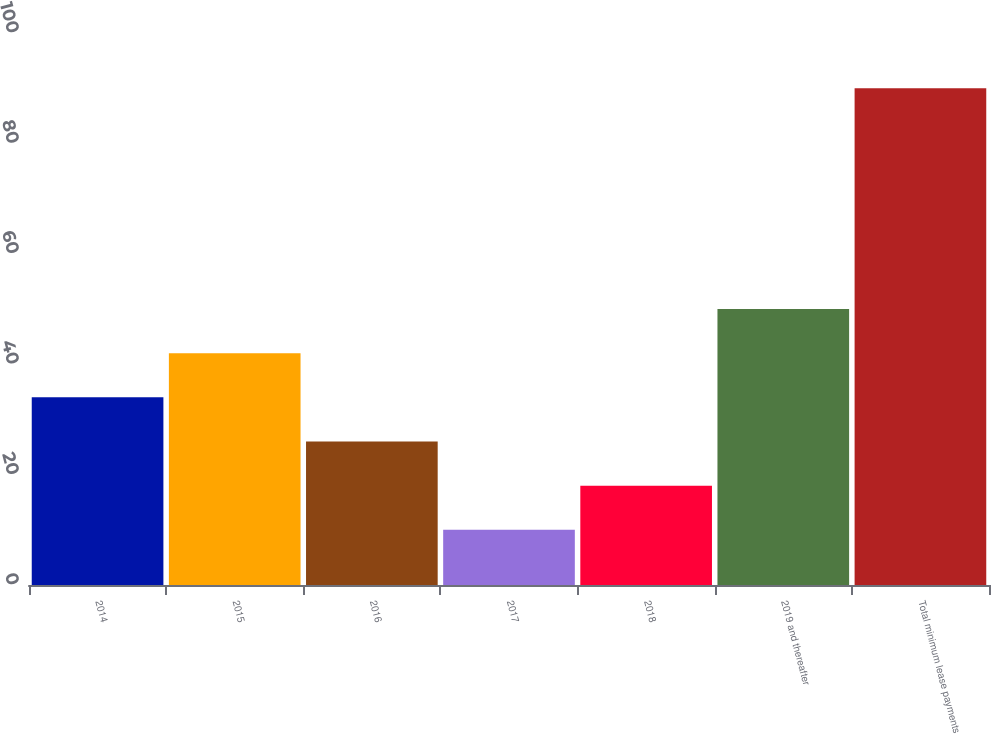Convert chart to OTSL. <chart><loc_0><loc_0><loc_500><loc_500><bar_chart><fcel>2014<fcel>2015<fcel>2016<fcel>2017<fcel>2018<fcel>2019 and thereafter<fcel>Total minimum lease payments<nl><fcel>34<fcel>42<fcel>26<fcel>10<fcel>18<fcel>50<fcel>90<nl></chart> 